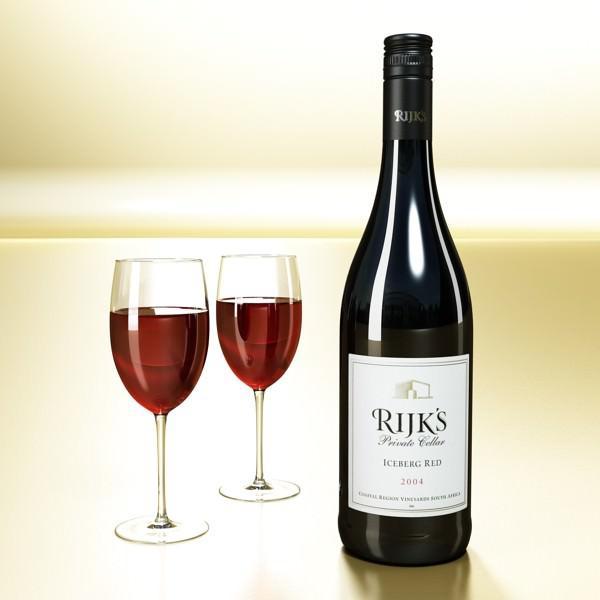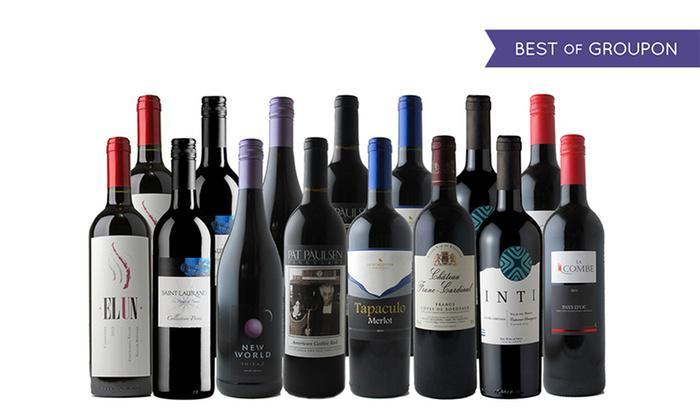The first image is the image on the left, the second image is the image on the right. Considering the images on both sides, is "A single bottle of wine is shown in one image." valid? Answer yes or no. Yes. The first image is the image on the left, the second image is the image on the right. Assess this claim about the two images: "An image includes at least one wine bottle and wine glass.". Correct or not? Answer yes or no. Yes. 